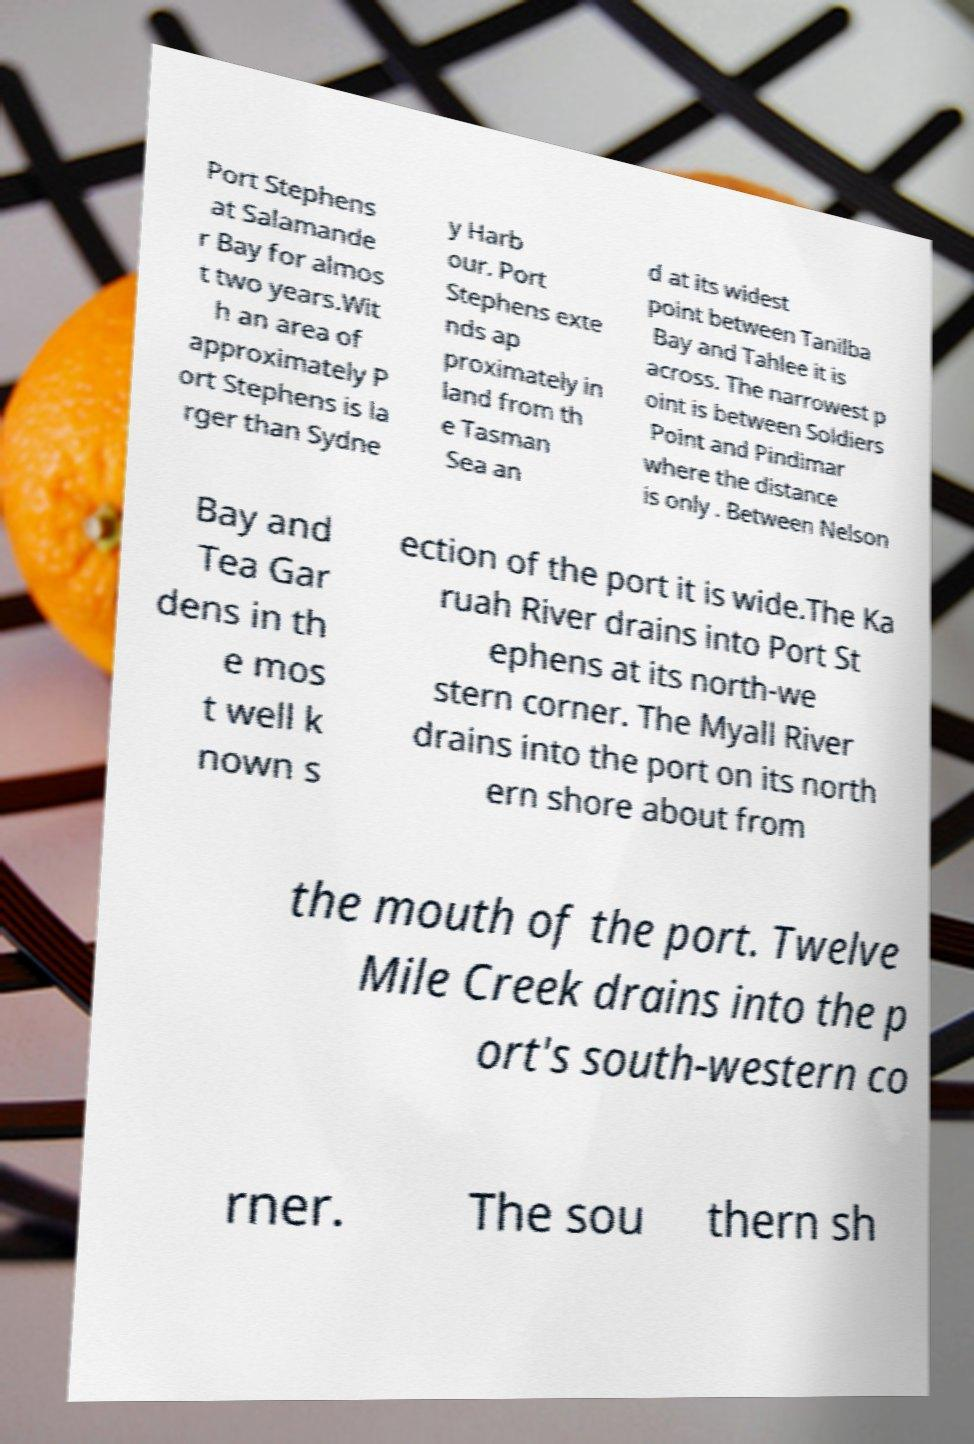There's text embedded in this image that I need extracted. Can you transcribe it verbatim? Port Stephens at Salamande r Bay for almos t two years.Wit h an area of approximately P ort Stephens is la rger than Sydne y Harb our. Port Stephens exte nds ap proximately in land from th e Tasman Sea an d at its widest point between Tanilba Bay and Tahlee it is across. The narrowest p oint is between Soldiers Point and Pindimar where the distance is only . Between Nelson Bay and Tea Gar dens in th e mos t well k nown s ection of the port it is wide.The Ka ruah River drains into Port St ephens at its north-we stern corner. The Myall River drains into the port on its north ern shore about from the mouth of the port. Twelve Mile Creek drains into the p ort's south-western co rner. The sou thern sh 